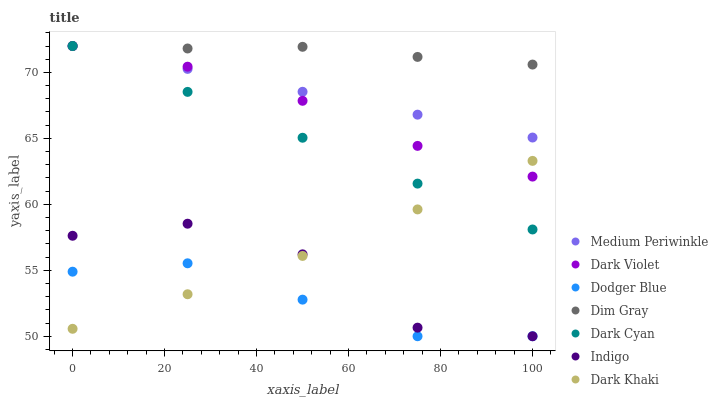Does Dodger Blue have the minimum area under the curve?
Answer yes or no. Yes. Does Dim Gray have the maximum area under the curve?
Answer yes or no. Yes. Does Indigo have the minimum area under the curve?
Answer yes or no. No. Does Indigo have the maximum area under the curve?
Answer yes or no. No. Is Dark Cyan the smoothest?
Answer yes or no. Yes. Is Indigo the roughest?
Answer yes or no. Yes. Is Medium Periwinkle the smoothest?
Answer yes or no. No. Is Medium Periwinkle the roughest?
Answer yes or no. No. Does Indigo have the lowest value?
Answer yes or no. Yes. Does Medium Periwinkle have the lowest value?
Answer yes or no. No. Does Dark Cyan have the highest value?
Answer yes or no. Yes. Does Indigo have the highest value?
Answer yes or no. No. Is Dark Khaki less than Medium Periwinkle?
Answer yes or no. Yes. Is Dark Violet greater than Dodger Blue?
Answer yes or no. Yes. Does Dark Cyan intersect Dark Khaki?
Answer yes or no. Yes. Is Dark Cyan less than Dark Khaki?
Answer yes or no. No. Is Dark Cyan greater than Dark Khaki?
Answer yes or no. No. Does Dark Khaki intersect Medium Periwinkle?
Answer yes or no. No. 